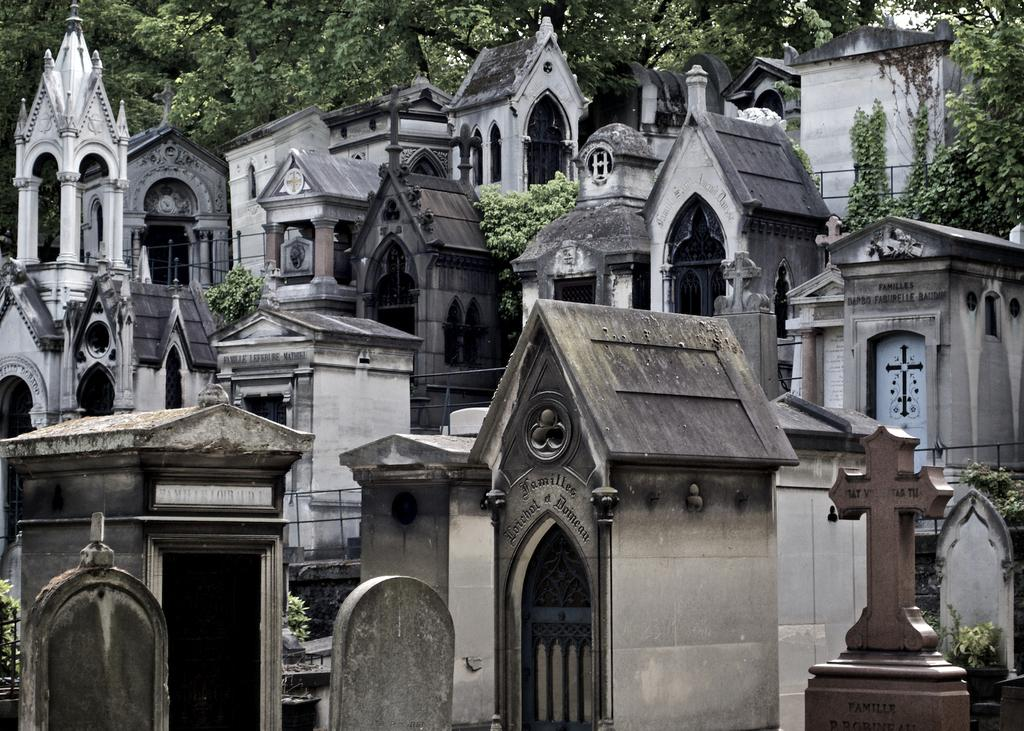Where was the image taken? The image was taken in a graveyard. What can be seen in the image besides the trees in the background? There are grave stones in the image. Can you describe the natural setting in the image? The natural setting includes trees in the background. What type of toys can be seen scattered around the grave stones in the image? There are no toys present in the image; it is a graveyard with grave stones and trees in the background. 